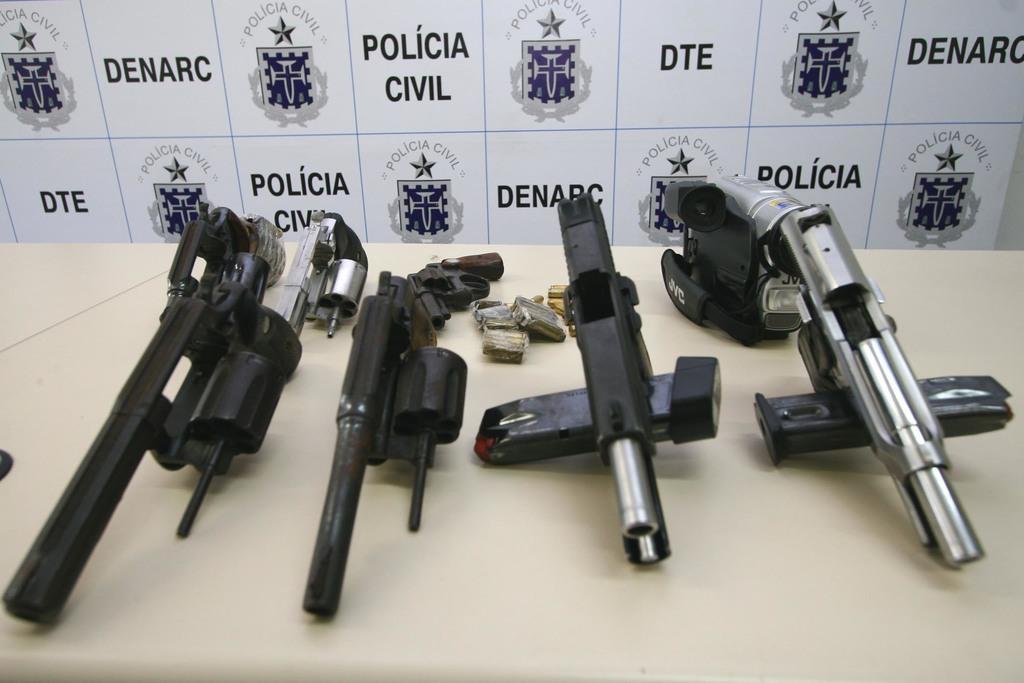Describe this image in one or two sentences. In the picture we can see different kinds of weapons are placed on the table. In the background, we can see a white color board on which we can see some logos and some edited text. 